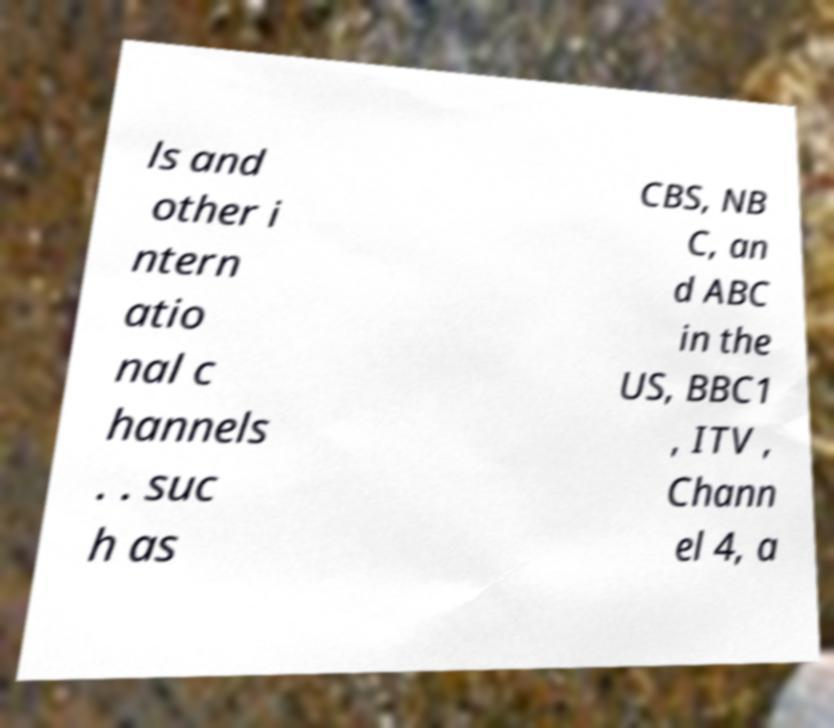I need the written content from this picture converted into text. Can you do that? ls and other i ntern atio nal c hannels . . suc h as CBS, NB C, an d ABC in the US, BBC1 , ITV , Chann el 4, a 